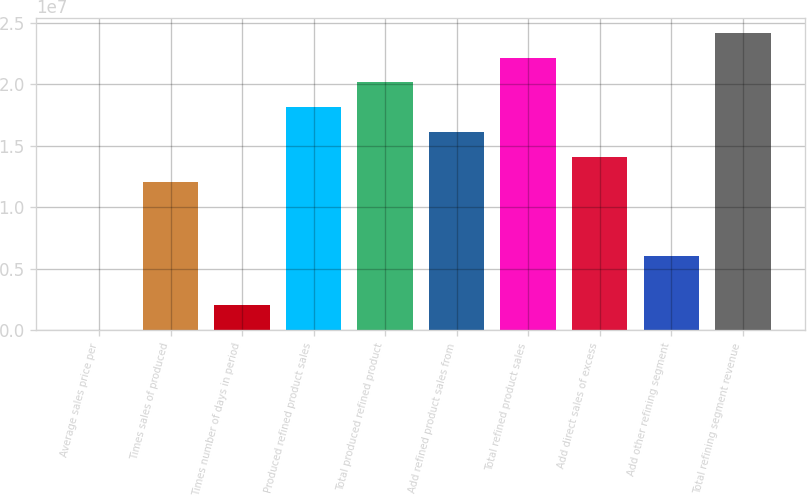Convert chart. <chart><loc_0><loc_0><loc_500><loc_500><bar_chart><fcel>Average sales price per<fcel>Times sales of produced<fcel>Times number of days in period<fcel>Produced refined product sales<fcel>Total produced refined product<fcel>Add refined product sales from<fcel>Total refined product sales<fcel>Add direct sales of excess<fcel>Add other refining segment<fcel>Total refining segment revenue<nl><fcel>115.6<fcel>1.20964e+07<fcel>2.01616e+06<fcel>1.81445e+07<fcel>2.01606e+07<fcel>1.61285e+07<fcel>2.21766e+07<fcel>1.41124e+07<fcel>6.04825e+06<fcel>2.41926e+07<nl></chart> 